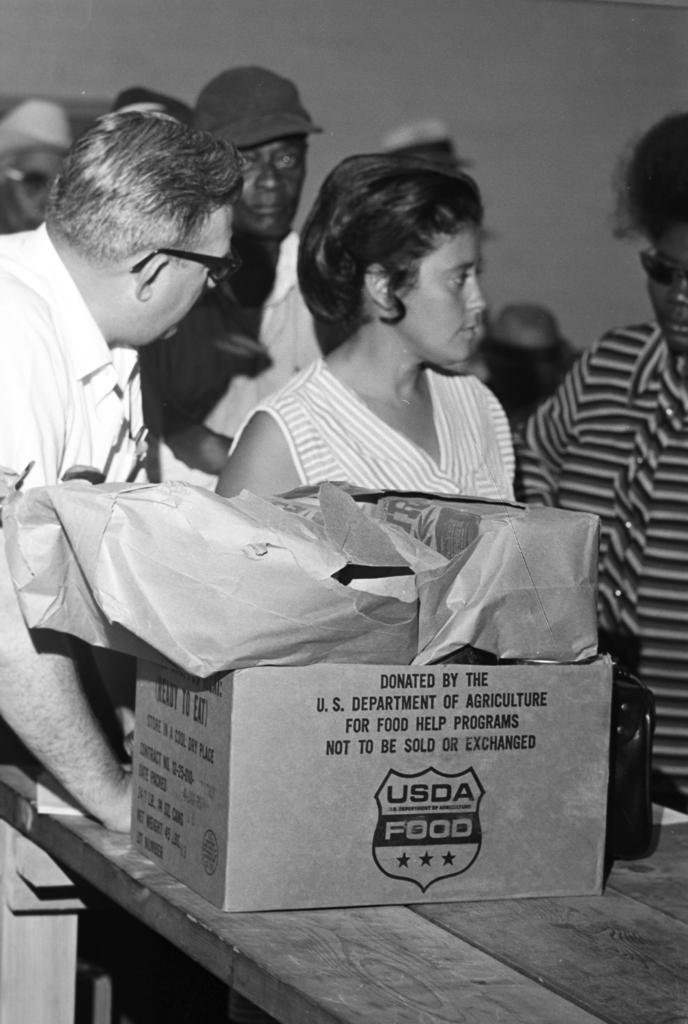Can you describe this image briefly? This is a black and white image. In this image we can see some people standing beside a table. We can also see some cardboard boxes placed on the table. 